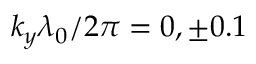Convert formula to latex. <formula><loc_0><loc_0><loc_500><loc_500>k _ { y } \lambda _ { 0 } / 2 \pi = 0 , \pm 0 . 1</formula> 